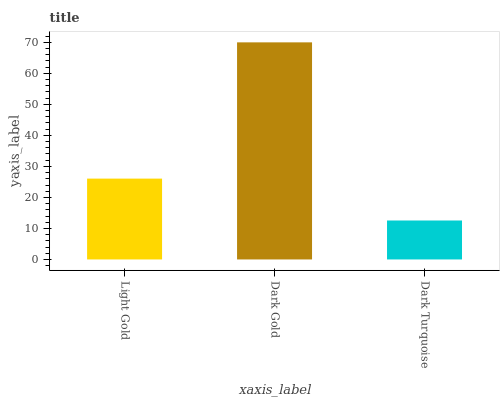Is Dark Turquoise the minimum?
Answer yes or no. Yes. Is Dark Gold the maximum?
Answer yes or no. Yes. Is Dark Gold the minimum?
Answer yes or no. No. Is Dark Turquoise the maximum?
Answer yes or no. No. Is Dark Gold greater than Dark Turquoise?
Answer yes or no. Yes. Is Dark Turquoise less than Dark Gold?
Answer yes or no. Yes. Is Dark Turquoise greater than Dark Gold?
Answer yes or no. No. Is Dark Gold less than Dark Turquoise?
Answer yes or no. No. Is Light Gold the high median?
Answer yes or no. Yes. Is Light Gold the low median?
Answer yes or no. Yes. Is Dark Gold the high median?
Answer yes or no. No. Is Dark Turquoise the low median?
Answer yes or no. No. 